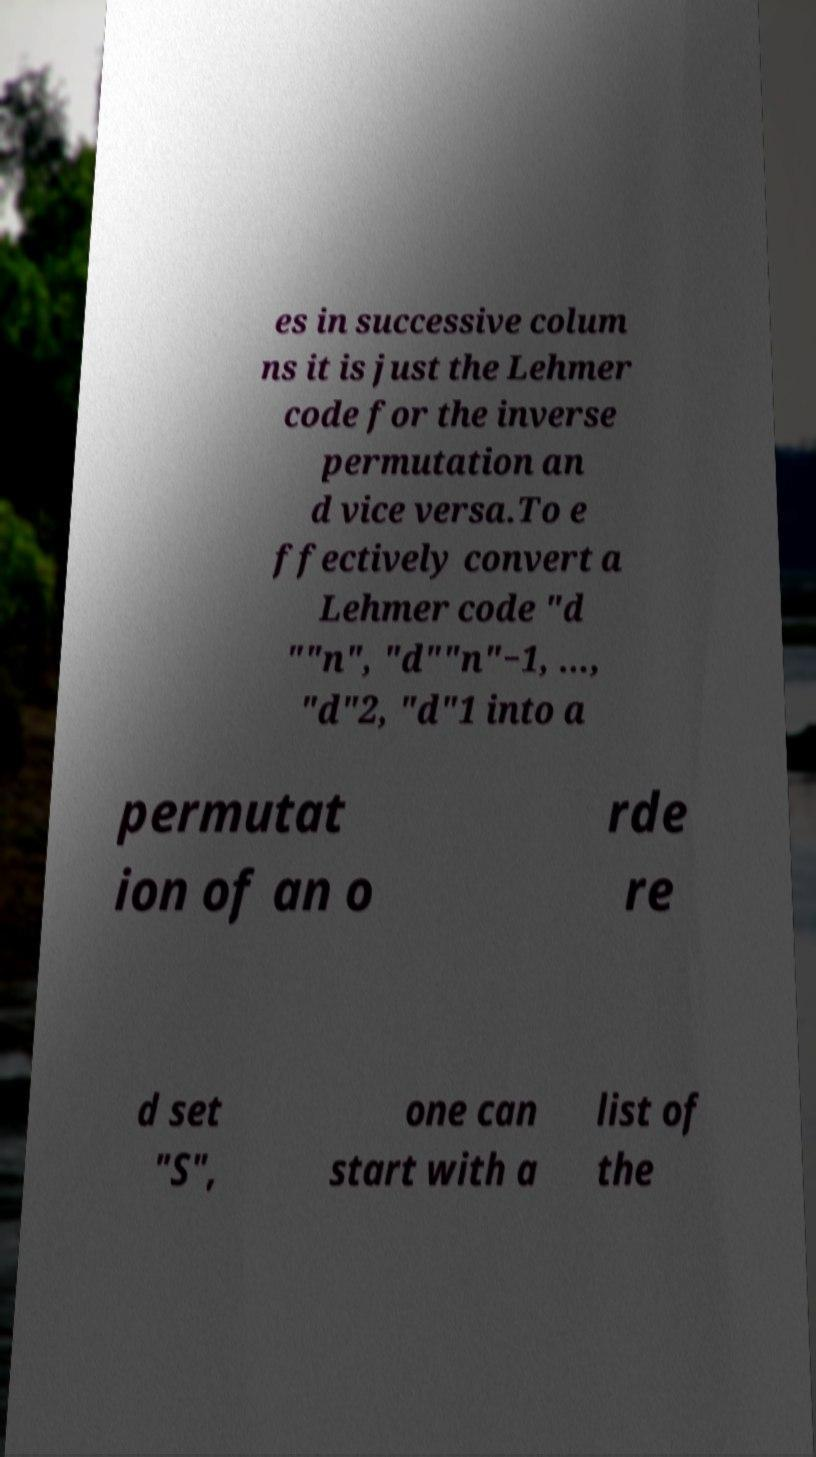Can you accurately transcribe the text from the provided image for me? es in successive colum ns it is just the Lehmer code for the inverse permutation an d vice versa.To e ffectively convert a Lehmer code "d ""n", "d""n"−1, ..., "d"2, "d"1 into a permutat ion of an o rde re d set "S", one can start with a list of the 